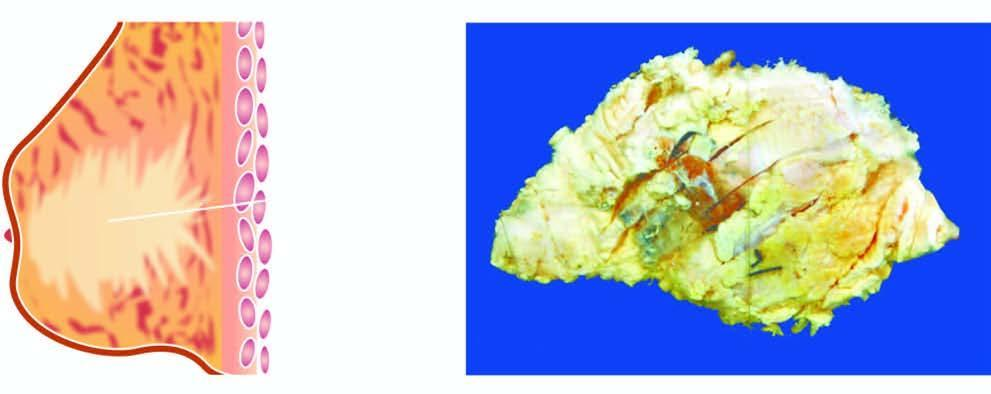does the breast show a tumour extending up to nipple and areola?
Answer the question using a single word or phrase. Yes 